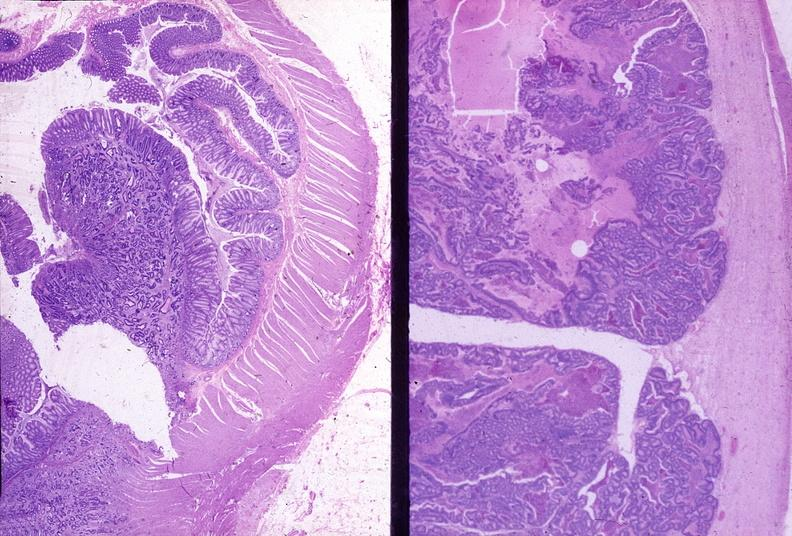does this image show colon, adenocarcinoma?
Answer the question using a single word or phrase. Yes 